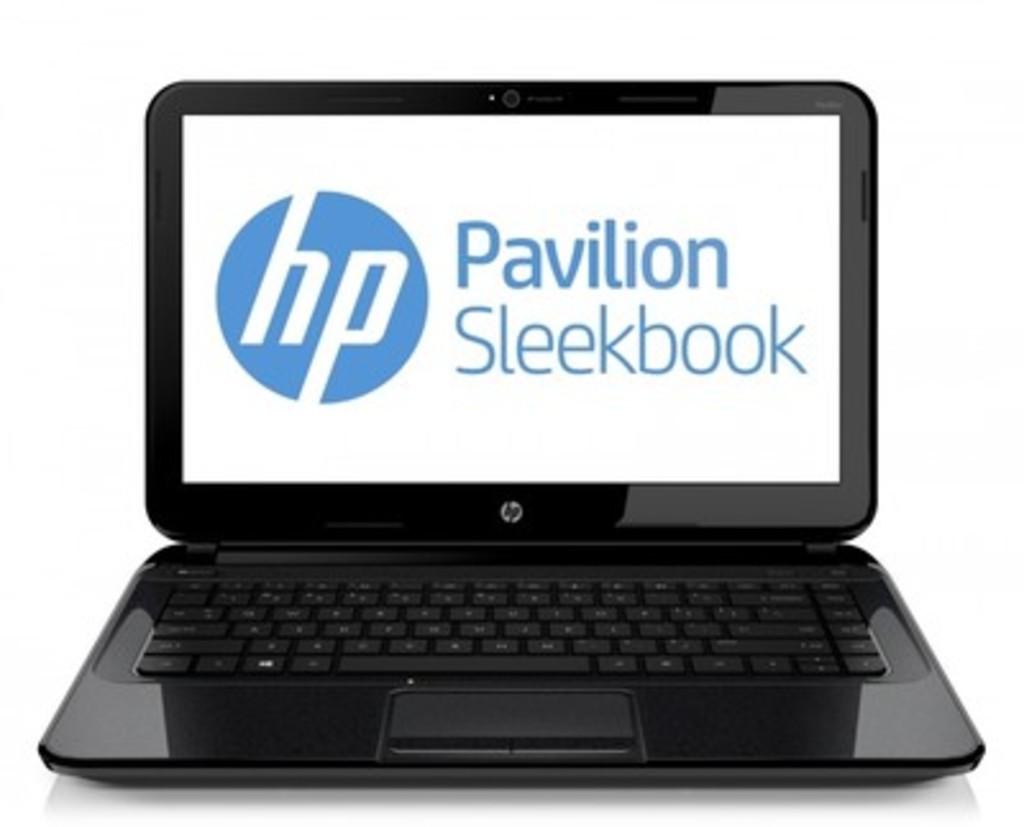What is the model of this hp laptop?
Offer a terse response. Pavilion sleekbook. What is the brand of this laptop?
Your answer should be very brief. Hp. 